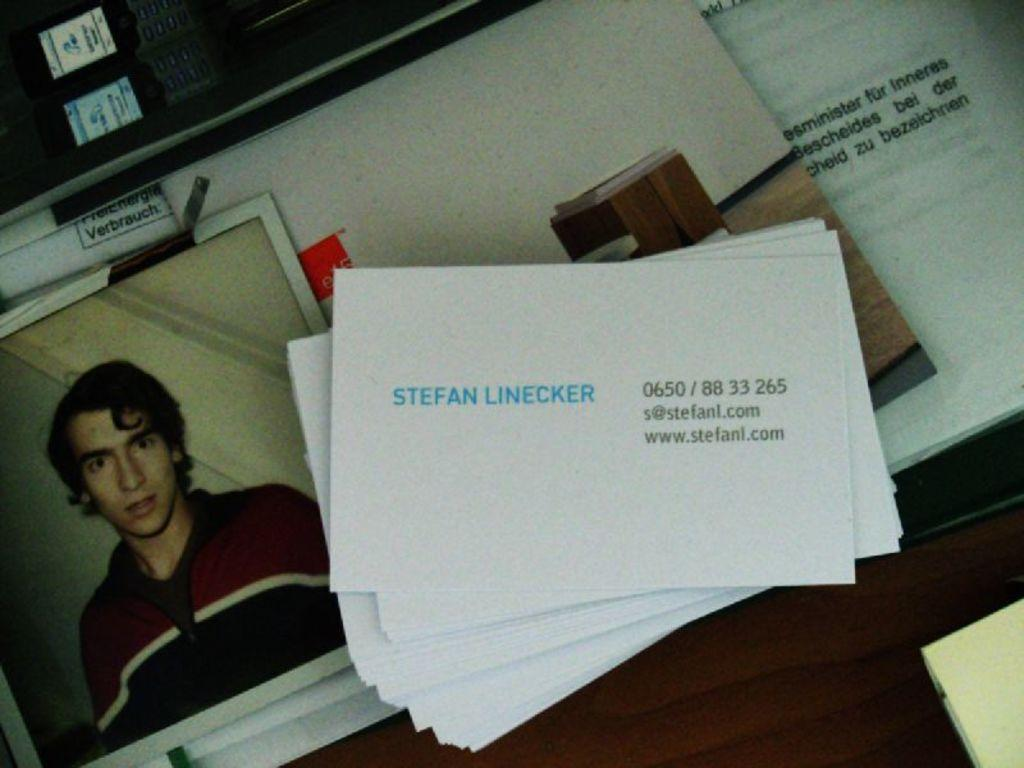<image>
Provide a brief description of the given image. A picture of a man with a card for Stefan Linecker 